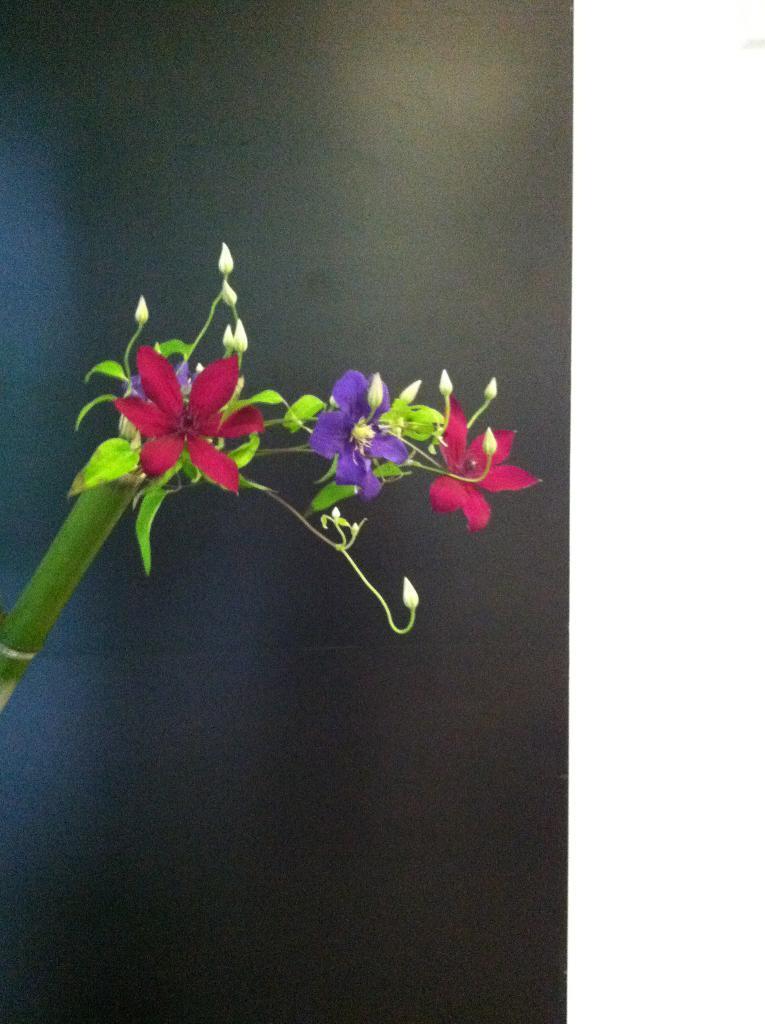In one or two sentences, can you explain what this image depicts? In this image we can see red and purple color flowers, leaves and stem. 